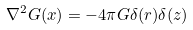Convert formula to latex. <formula><loc_0><loc_0><loc_500><loc_500>\nabla ^ { 2 } G ( x ) = - 4 \pi G \delta ( r ) \delta ( z )</formula> 